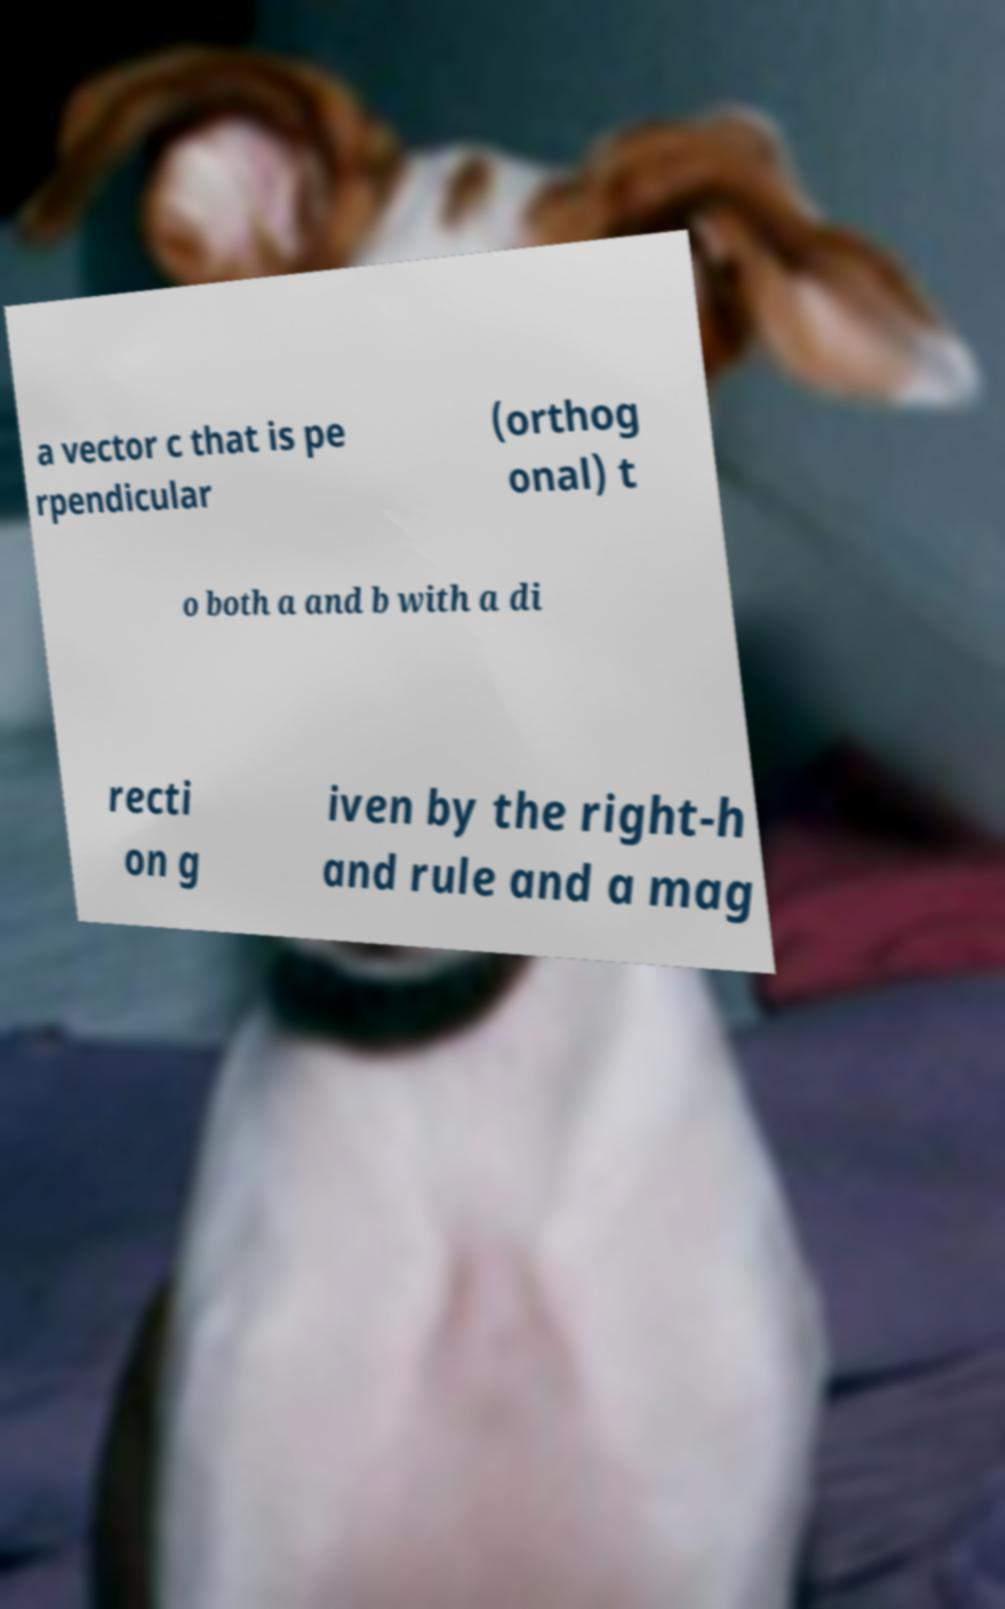Can you read and provide the text displayed in the image?This photo seems to have some interesting text. Can you extract and type it out for me? a vector c that is pe rpendicular (orthog onal) t o both a and b with a di recti on g iven by the right-h and rule and a mag 